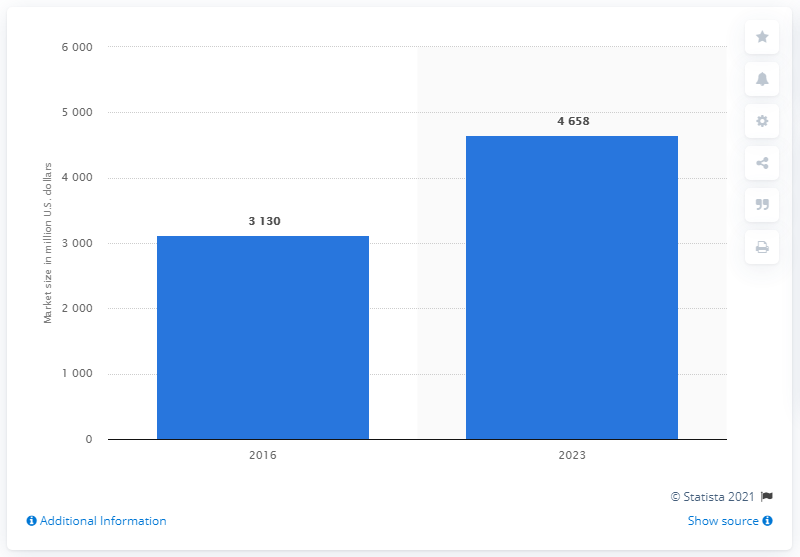Can you tell me what this chart is representing? This bar chart appears to represent the market size in trillion U.S. dollars for a specific industry or sector, comparing the years 2016 and 2023. 